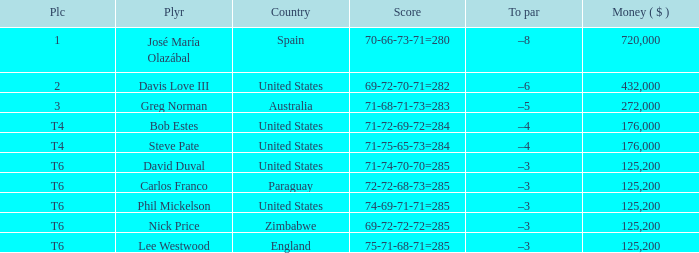Which Score has a Place of 3? 71-68-71-73=283. 